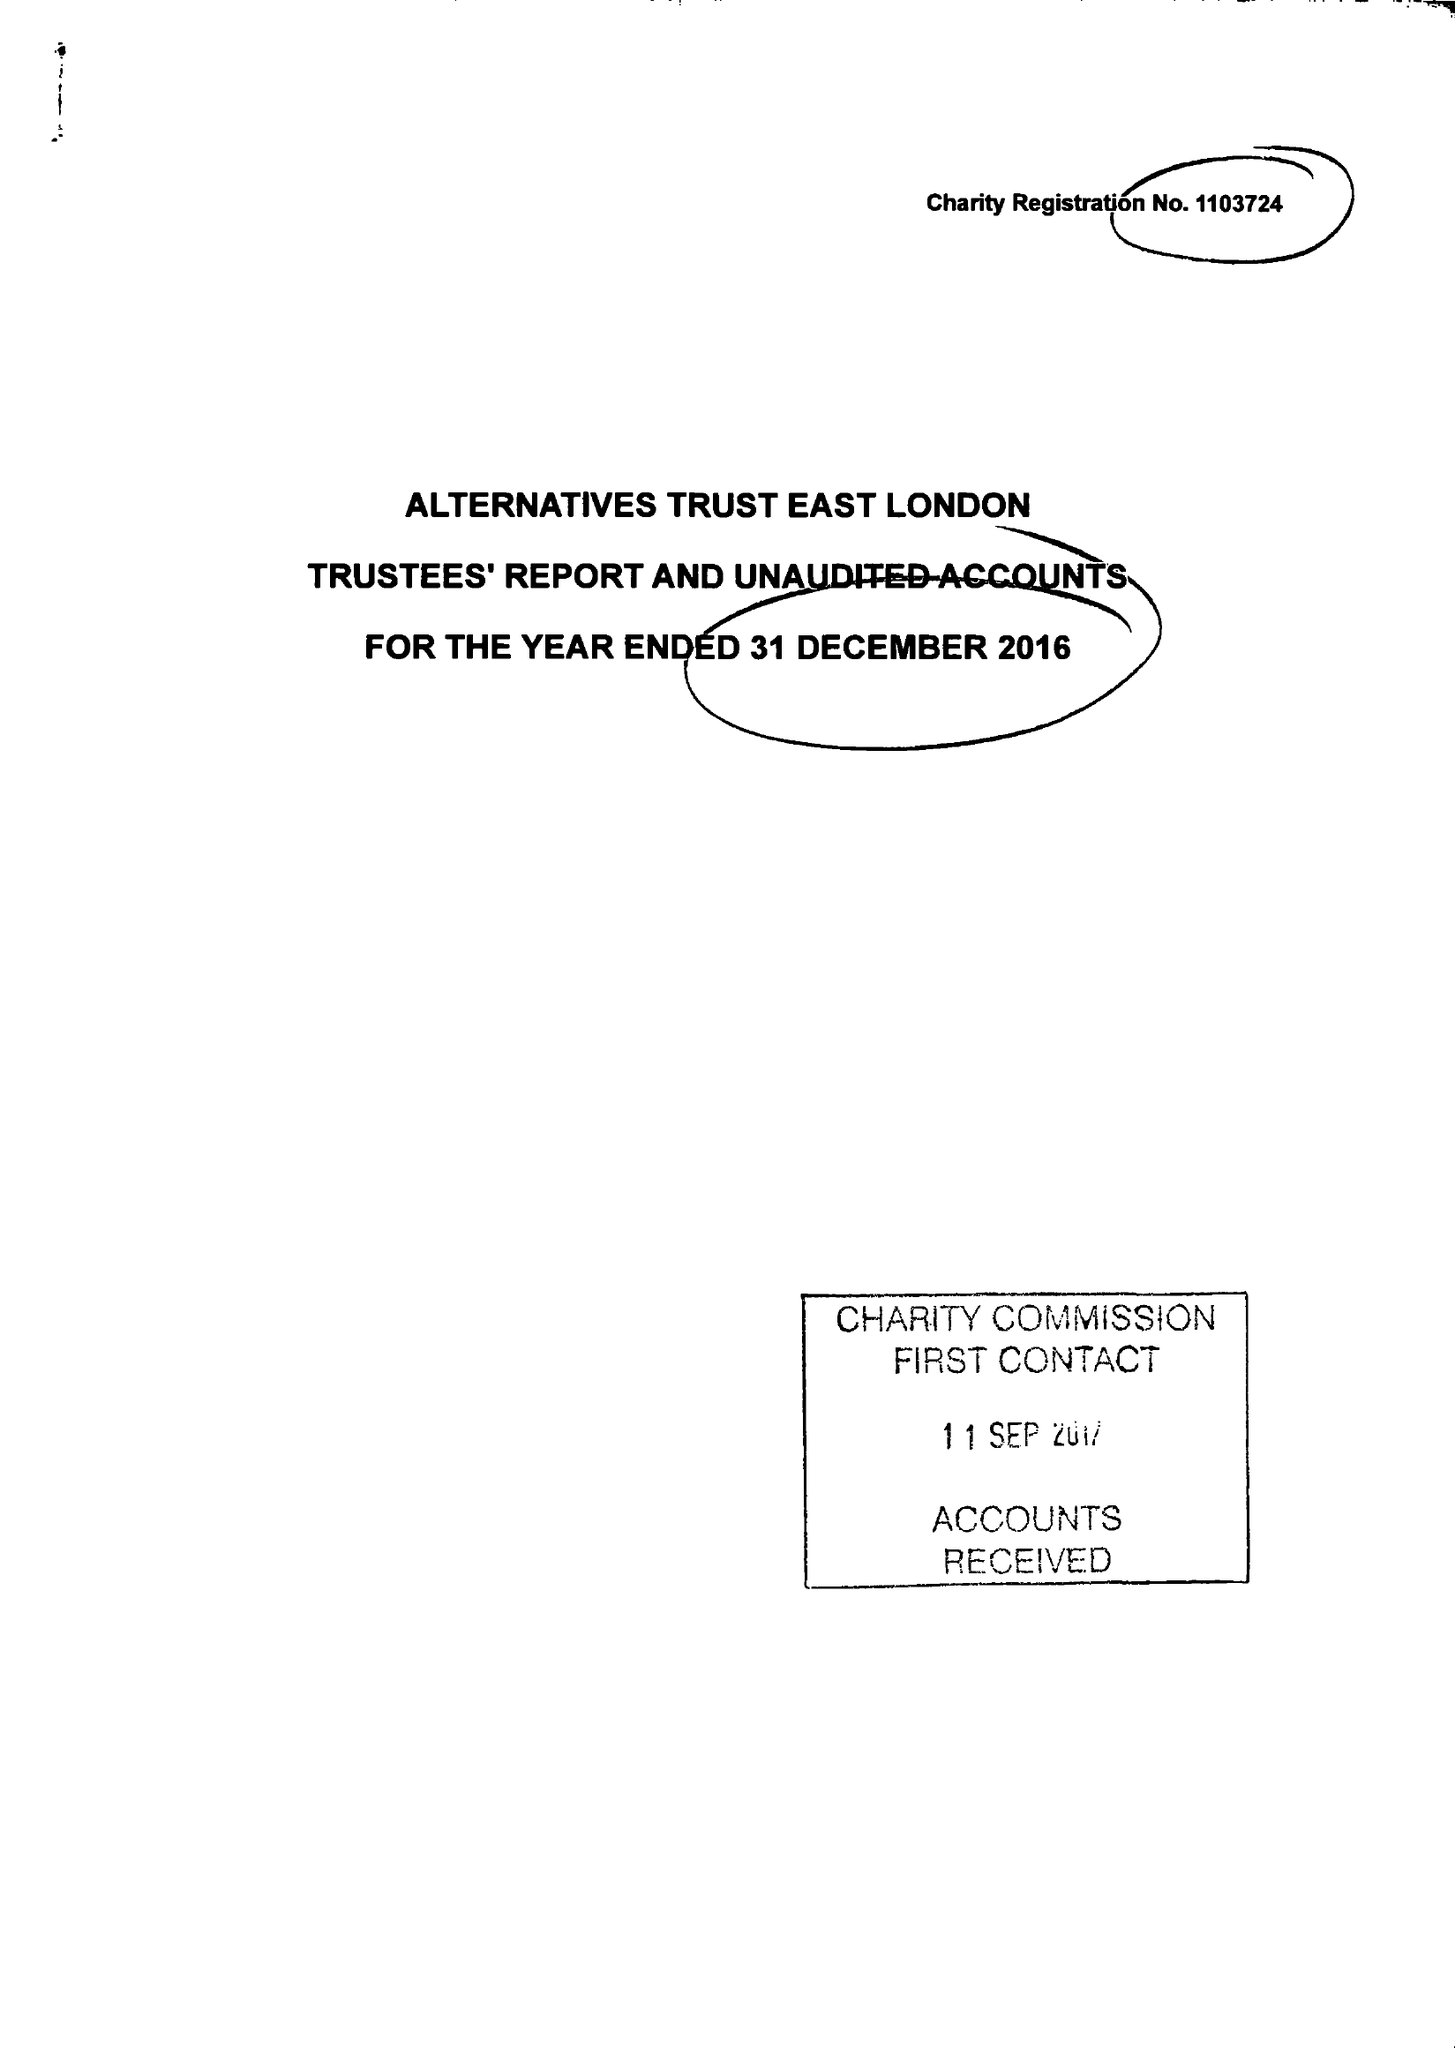What is the value for the income_annually_in_british_pounds?
Answer the question using a single word or phrase. 180563.00 